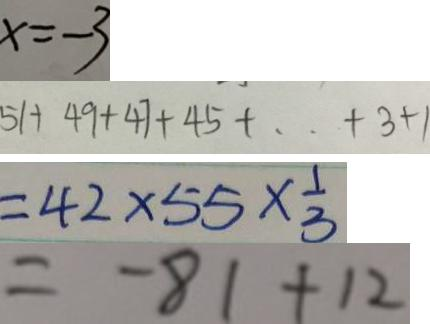Convert formula to latex. <formula><loc_0><loc_0><loc_500><loc_500>x = - 3 
 5 1 + 4 9 + 4 7 + 4 5 + \cdots + 3 + 1 
 = 4 2 \times 5 5 \times \frac { 1 } { 3 } 
 = - 8 1 + 1 2</formula> 